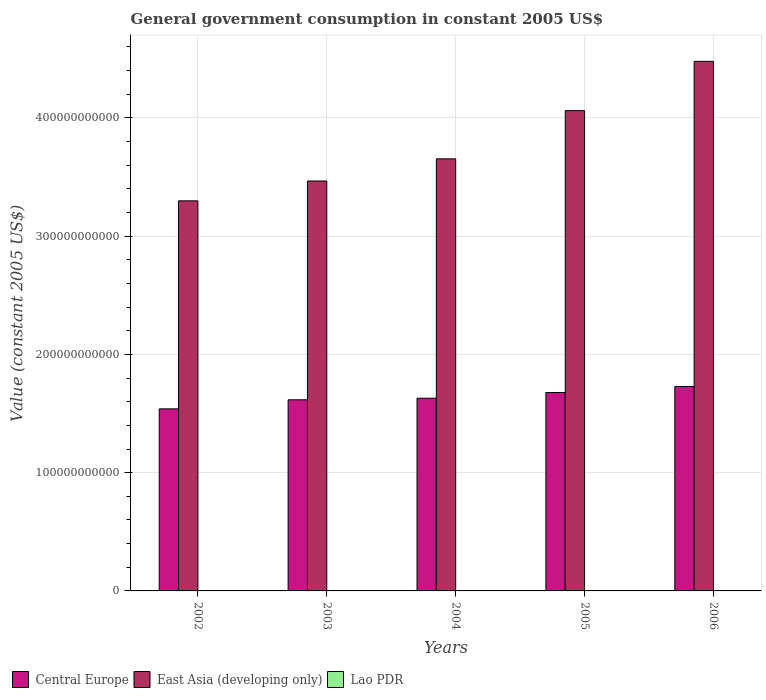How many different coloured bars are there?
Provide a short and direct response. 3. Are the number of bars on each tick of the X-axis equal?
Keep it short and to the point. Yes. How many bars are there on the 4th tick from the left?
Provide a succinct answer. 3. What is the label of the 2nd group of bars from the left?
Make the answer very short. 2003. In how many cases, is the number of bars for a given year not equal to the number of legend labels?
Offer a very short reply. 0. What is the government conusmption in Central Europe in 2003?
Your answer should be compact. 1.62e+11. Across all years, what is the maximum government conusmption in Lao PDR?
Your answer should be compact. 2.48e+08. Across all years, what is the minimum government conusmption in Central Europe?
Keep it short and to the point. 1.54e+11. In which year was the government conusmption in Central Europe maximum?
Make the answer very short. 2006. What is the total government conusmption in East Asia (developing only) in the graph?
Provide a short and direct response. 1.90e+12. What is the difference between the government conusmption in Central Europe in 2003 and that in 2005?
Keep it short and to the point. -6.17e+09. What is the difference between the government conusmption in East Asia (developing only) in 2005 and the government conusmption in Lao PDR in 2004?
Offer a very short reply. 4.06e+11. What is the average government conusmption in Lao PDR per year?
Your answer should be very brief. 1.93e+08. In the year 2002, what is the difference between the government conusmption in East Asia (developing only) and government conusmption in Central Europe?
Your answer should be compact. 1.76e+11. What is the ratio of the government conusmption in East Asia (developing only) in 2002 to that in 2004?
Your answer should be very brief. 0.9. Is the difference between the government conusmption in East Asia (developing only) in 2003 and 2004 greater than the difference between the government conusmption in Central Europe in 2003 and 2004?
Keep it short and to the point. No. What is the difference between the highest and the second highest government conusmption in East Asia (developing only)?
Offer a terse response. 4.17e+1. What is the difference between the highest and the lowest government conusmption in Lao PDR?
Your answer should be compact. 9.34e+07. In how many years, is the government conusmption in Lao PDR greater than the average government conusmption in Lao PDR taken over all years?
Provide a short and direct response. 2. What does the 3rd bar from the left in 2004 represents?
Offer a very short reply. Lao PDR. What does the 3rd bar from the right in 2003 represents?
Provide a succinct answer. Central Europe. Is it the case that in every year, the sum of the government conusmption in Lao PDR and government conusmption in East Asia (developing only) is greater than the government conusmption in Central Europe?
Provide a short and direct response. Yes. What is the difference between two consecutive major ticks on the Y-axis?
Your response must be concise. 1.00e+11. Are the values on the major ticks of Y-axis written in scientific E-notation?
Your response must be concise. No. Does the graph contain grids?
Provide a succinct answer. Yes. How many legend labels are there?
Give a very brief answer. 3. How are the legend labels stacked?
Offer a terse response. Horizontal. What is the title of the graph?
Your answer should be very brief. General government consumption in constant 2005 US$. Does "Kenya" appear as one of the legend labels in the graph?
Give a very brief answer. No. What is the label or title of the X-axis?
Your response must be concise. Years. What is the label or title of the Y-axis?
Provide a short and direct response. Value (constant 2005 US$). What is the Value (constant 2005 US$) of Central Europe in 2002?
Your answer should be very brief. 1.54e+11. What is the Value (constant 2005 US$) in East Asia (developing only) in 2002?
Make the answer very short. 3.30e+11. What is the Value (constant 2005 US$) in Lao PDR in 2002?
Your answer should be compact. 1.55e+08. What is the Value (constant 2005 US$) in Central Europe in 2003?
Give a very brief answer. 1.62e+11. What is the Value (constant 2005 US$) of East Asia (developing only) in 2003?
Give a very brief answer. 3.47e+11. What is the Value (constant 2005 US$) of Lao PDR in 2003?
Give a very brief answer. 1.64e+08. What is the Value (constant 2005 US$) of Central Europe in 2004?
Give a very brief answer. 1.63e+11. What is the Value (constant 2005 US$) of East Asia (developing only) in 2004?
Keep it short and to the point. 3.65e+11. What is the Value (constant 2005 US$) of Lao PDR in 2004?
Offer a terse response. 1.79e+08. What is the Value (constant 2005 US$) in Central Europe in 2005?
Your answer should be very brief. 1.68e+11. What is the Value (constant 2005 US$) in East Asia (developing only) in 2005?
Your answer should be compact. 4.06e+11. What is the Value (constant 2005 US$) in Lao PDR in 2005?
Keep it short and to the point. 2.22e+08. What is the Value (constant 2005 US$) of Central Europe in 2006?
Provide a short and direct response. 1.73e+11. What is the Value (constant 2005 US$) of East Asia (developing only) in 2006?
Provide a short and direct response. 4.48e+11. What is the Value (constant 2005 US$) in Lao PDR in 2006?
Provide a short and direct response. 2.48e+08. Across all years, what is the maximum Value (constant 2005 US$) of Central Europe?
Ensure brevity in your answer.  1.73e+11. Across all years, what is the maximum Value (constant 2005 US$) in East Asia (developing only)?
Provide a short and direct response. 4.48e+11. Across all years, what is the maximum Value (constant 2005 US$) of Lao PDR?
Your answer should be very brief. 2.48e+08. Across all years, what is the minimum Value (constant 2005 US$) of Central Europe?
Make the answer very short. 1.54e+11. Across all years, what is the minimum Value (constant 2005 US$) of East Asia (developing only)?
Your answer should be compact. 3.30e+11. Across all years, what is the minimum Value (constant 2005 US$) of Lao PDR?
Provide a succinct answer. 1.55e+08. What is the total Value (constant 2005 US$) of Central Europe in the graph?
Your response must be concise. 8.19e+11. What is the total Value (constant 2005 US$) in East Asia (developing only) in the graph?
Offer a terse response. 1.90e+12. What is the total Value (constant 2005 US$) of Lao PDR in the graph?
Your answer should be compact. 9.67e+08. What is the difference between the Value (constant 2005 US$) of Central Europe in 2002 and that in 2003?
Your answer should be compact. -7.67e+09. What is the difference between the Value (constant 2005 US$) in East Asia (developing only) in 2002 and that in 2003?
Your answer should be compact. -1.68e+1. What is the difference between the Value (constant 2005 US$) of Lao PDR in 2002 and that in 2003?
Your answer should be compact. -9.44e+06. What is the difference between the Value (constant 2005 US$) of Central Europe in 2002 and that in 2004?
Your answer should be compact. -9.01e+09. What is the difference between the Value (constant 2005 US$) of East Asia (developing only) in 2002 and that in 2004?
Offer a terse response. -3.55e+1. What is the difference between the Value (constant 2005 US$) in Lao PDR in 2002 and that in 2004?
Provide a short and direct response. -2.40e+07. What is the difference between the Value (constant 2005 US$) in Central Europe in 2002 and that in 2005?
Your answer should be very brief. -1.38e+1. What is the difference between the Value (constant 2005 US$) in East Asia (developing only) in 2002 and that in 2005?
Give a very brief answer. -7.63e+1. What is the difference between the Value (constant 2005 US$) of Lao PDR in 2002 and that in 2005?
Provide a succinct answer. -6.69e+07. What is the difference between the Value (constant 2005 US$) of Central Europe in 2002 and that in 2006?
Ensure brevity in your answer.  -1.89e+1. What is the difference between the Value (constant 2005 US$) of East Asia (developing only) in 2002 and that in 2006?
Provide a short and direct response. -1.18e+11. What is the difference between the Value (constant 2005 US$) of Lao PDR in 2002 and that in 2006?
Your answer should be compact. -9.34e+07. What is the difference between the Value (constant 2005 US$) in Central Europe in 2003 and that in 2004?
Keep it short and to the point. -1.34e+09. What is the difference between the Value (constant 2005 US$) of East Asia (developing only) in 2003 and that in 2004?
Make the answer very short. -1.87e+1. What is the difference between the Value (constant 2005 US$) of Lao PDR in 2003 and that in 2004?
Give a very brief answer. -1.46e+07. What is the difference between the Value (constant 2005 US$) in Central Europe in 2003 and that in 2005?
Ensure brevity in your answer.  -6.17e+09. What is the difference between the Value (constant 2005 US$) in East Asia (developing only) in 2003 and that in 2005?
Your response must be concise. -5.95e+1. What is the difference between the Value (constant 2005 US$) in Lao PDR in 2003 and that in 2005?
Make the answer very short. -5.75e+07. What is the difference between the Value (constant 2005 US$) in Central Europe in 2003 and that in 2006?
Give a very brief answer. -1.12e+1. What is the difference between the Value (constant 2005 US$) of East Asia (developing only) in 2003 and that in 2006?
Offer a very short reply. -1.01e+11. What is the difference between the Value (constant 2005 US$) of Lao PDR in 2003 and that in 2006?
Provide a succinct answer. -8.39e+07. What is the difference between the Value (constant 2005 US$) of Central Europe in 2004 and that in 2005?
Provide a succinct answer. -4.83e+09. What is the difference between the Value (constant 2005 US$) in East Asia (developing only) in 2004 and that in 2005?
Provide a short and direct response. -4.07e+1. What is the difference between the Value (constant 2005 US$) of Lao PDR in 2004 and that in 2005?
Offer a terse response. -4.29e+07. What is the difference between the Value (constant 2005 US$) in Central Europe in 2004 and that in 2006?
Your answer should be compact. -9.87e+09. What is the difference between the Value (constant 2005 US$) of East Asia (developing only) in 2004 and that in 2006?
Provide a short and direct response. -8.24e+1. What is the difference between the Value (constant 2005 US$) of Lao PDR in 2004 and that in 2006?
Your answer should be compact. -6.93e+07. What is the difference between the Value (constant 2005 US$) of Central Europe in 2005 and that in 2006?
Keep it short and to the point. -5.04e+09. What is the difference between the Value (constant 2005 US$) in East Asia (developing only) in 2005 and that in 2006?
Make the answer very short. -4.17e+1. What is the difference between the Value (constant 2005 US$) of Lao PDR in 2005 and that in 2006?
Offer a terse response. -2.64e+07. What is the difference between the Value (constant 2005 US$) in Central Europe in 2002 and the Value (constant 2005 US$) in East Asia (developing only) in 2003?
Make the answer very short. -1.93e+11. What is the difference between the Value (constant 2005 US$) in Central Europe in 2002 and the Value (constant 2005 US$) in Lao PDR in 2003?
Your response must be concise. 1.54e+11. What is the difference between the Value (constant 2005 US$) of East Asia (developing only) in 2002 and the Value (constant 2005 US$) of Lao PDR in 2003?
Provide a succinct answer. 3.30e+11. What is the difference between the Value (constant 2005 US$) of Central Europe in 2002 and the Value (constant 2005 US$) of East Asia (developing only) in 2004?
Your response must be concise. -2.11e+11. What is the difference between the Value (constant 2005 US$) of Central Europe in 2002 and the Value (constant 2005 US$) of Lao PDR in 2004?
Your answer should be compact. 1.54e+11. What is the difference between the Value (constant 2005 US$) of East Asia (developing only) in 2002 and the Value (constant 2005 US$) of Lao PDR in 2004?
Provide a succinct answer. 3.30e+11. What is the difference between the Value (constant 2005 US$) in Central Europe in 2002 and the Value (constant 2005 US$) in East Asia (developing only) in 2005?
Ensure brevity in your answer.  -2.52e+11. What is the difference between the Value (constant 2005 US$) of Central Europe in 2002 and the Value (constant 2005 US$) of Lao PDR in 2005?
Give a very brief answer. 1.54e+11. What is the difference between the Value (constant 2005 US$) of East Asia (developing only) in 2002 and the Value (constant 2005 US$) of Lao PDR in 2005?
Your response must be concise. 3.30e+11. What is the difference between the Value (constant 2005 US$) of Central Europe in 2002 and the Value (constant 2005 US$) of East Asia (developing only) in 2006?
Keep it short and to the point. -2.94e+11. What is the difference between the Value (constant 2005 US$) of Central Europe in 2002 and the Value (constant 2005 US$) of Lao PDR in 2006?
Your response must be concise. 1.54e+11. What is the difference between the Value (constant 2005 US$) in East Asia (developing only) in 2002 and the Value (constant 2005 US$) in Lao PDR in 2006?
Offer a terse response. 3.30e+11. What is the difference between the Value (constant 2005 US$) of Central Europe in 2003 and the Value (constant 2005 US$) of East Asia (developing only) in 2004?
Give a very brief answer. -2.04e+11. What is the difference between the Value (constant 2005 US$) in Central Europe in 2003 and the Value (constant 2005 US$) in Lao PDR in 2004?
Offer a very short reply. 1.61e+11. What is the difference between the Value (constant 2005 US$) of East Asia (developing only) in 2003 and the Value (constant 2005 US$) of Lao PDR in 2004?
Make the answer very short. 3.46e+11. What is the difference between the Value (constant 2005 US$) in Central Europe in 2003 and the Value (constant 2005 US$) in East Asia (developing only) in 2005?
Ensure brevity in your answer.  -2.44e+11. What is the difference between the Value (constant 2005 US$) of Central Europe in 2003 and the Value (constant 2005 US$) of Lao PDR in 2005?
Your answer should be compact. 1.61e+11. What is the difference between the Value (constant 2005 US$) of East Asia (developing only) in 2003 and the Value (constant 2005 US$) of Lao PDR in 2005?
Provide a succinct answer. 3.46e+11. What is the difference between the Value (constant 2005 US$) of Central Europe in 2003 and the Value (constant 2005 US$) of East Asia (developing only) in 2006?
Your response must be concise. -2.86e+11. What is the difference between the Value (constant 2005 US$) in Central Europe in 2003 and the Value (constant 2005 US$) in Lao PDR in 2006?
Provide a short and direct response. 1.61e+11. What is the difference between the Value (constant 2005 US$) in East Asia (developing only) in 2003 and the Value (constant 2005 US$) in Lao PDR in 2006?
Give a very brief answer. 3.46e+11. What is the difference between the Value (constant 2005 US$) of Central Europe in 2004 and the Value (constant 2005 US$) of East Asia (developing only) in 2005?
Give a very brief answer. -2.43e+11. What is the difference between the Value (constant 2005 US$) in Central Europe in 2004 and the Value (constant 2005 US$) in Lao PDR in 2005?
Offer a terse response. 1.63e+11. What is the difference between the Value (constant 2005 US$) in East Asia (developing only) in 2004 and the Value (constant 2005 US$) in Lao PDR in 2005?
Offer a terse response. 3.65e+11. What is the difference between the Value (constant 2005 US$) of Central Europe in 2004 and the Value (constant 2005 US$) of East Asia (developing only) in 2006?
Provide a succinct answer. -2.85e+11. What is the difference between the Value (constant 2005 US$) in Central Europe in 2004 and the Value (constant 2005 US$) in Lao PDR in 2006?
Give a very brief answer. 1.63e+11. What is the difference between the Value (constant 2005 US$) in East Asia (developing only) in 2004 and the Value (constant 2005 US$) in Lao PDR in 2006?
Ensure brevity in your answer.  3.65e+11. What is the difference between the Value (constant 2005 US$) of Central Europe in 2005 and the Value (constant 2005 US$) of East Asia (developing only) in 2006?
Keep it short and to the point. -2.80e+11. What is the difference between the Value (constant 2005 US$) in Central Europe in 2005 and the Value (constant 2005 US$) in Lao PDR in 2006?
Keep it short and to the point. 1.68e+11. What is the difference between the Value (constant 2005 US$) in East Asia (developing only) in 2005 and the Value (constant 2005 US$) in Lao PDR in 2006?
Your answer should be very brief. 4.06e+11. What is the average Value (constant 2005 US$) of Central Europe per year?
Ensure brevity in your answer.  1.64e+11. What is the average Value (constant 2005 US$) in East Asia (developing only) per year?
Offer a very short reply. 3.79e+11. What is the average Value (constant 2005 US$) in Lao PDR per year?
Your answer should be very brief. 1.93e+08. In the year 2002, what is the difference between the Value (constant 2005 US$) in Central Europe and Value (constant 2005 US$) in East Asia (developing only)?
Provide a succinct answer. -1.76e+11. In the year 2002, what is the difference between the Value (constant 2005 US$) of Central Europe and Value (constant 2005 US$) of Lao PDR?
Offer a very short reply. 1.54e+11. In the year 2002, what is the difference between the Value (constant 2005 US$) in East Asia (developing only) and Value (constant 2005 US$) in Lao PDR?
Offer a very short reply. 3.30e+11. In the year 2003, what is the difference between the Value (constant 2005 US$) in Central Europe and Value (constant 2005 US$) in East Asia (developing only)?
Your response must be concise. -1.85e+11. In the year 2003, what is the difference between the Value (constant 2005 US$) of Central Europe and Value (constant 2005 US$) of Lao PDR?
Provide a succinct answer. 1.61e+11. In the year 2003, what is the difference between the Value (constant 2005 US$) of East Asia (developing only) and Value (constant 2005 US$) of Lao PDR?
Your answer should be compact. 3.46e+11. In the year 2004, what is the difference between the Value (constant 2005 US$) in Central Europe and Value (constant 2005 US$) in East Asia (developing only)?
Your response must be concise. -2.02e+11. In the year 2004, what is the difference between the Value (constant 2005 US$) of Central Europe and Value (constant 2005 US$) of Lao PDR?
Your answer should be very brief. 1.63e+11. In the year 2004, what is the difference between the Value (constant 2005 US$) in East Asia (developing only) and Value (constant 2005 US$) in Lao PDR?
Keep it short and to the point. 3.65e+11. In the year 2005, what is the difference between the Value (constant 2005 US$) in Central Europe and Value (constant 2005 US$) in East Asia (developing only)?
Offer a terse response. -2.38e+11. In the year 2005, what is the difference between the Value (constant 2005 US$) in Central Europe and Value (constant 2005 US$) in Lao PDR?
Offer a very short reply. 1.68e+11. In the year 2005, what is the difference between the Value (constant 2005 US$) of East Asia (developing only) and Value (constant 2005 US$) of Lao PDR?
Make the answer very short. 4.06e+11. In the year 2006, what is the difference between the Value (constant 2005 US$) in Central Europe and Value (constant 2005 US$) in East Asia (developing only)?
Ensure brevity in your answer.  -2.75e+11. In the year 2006, what is the difference between the Value (constant 2005 US$) of Central Europe and Value (constant 2005 US$) of Lao PDR?
Offer a very short reply. 1.73e+11. In the year 2006, what is the difference between the Value (constant 2005 US$) in East Asia (developing only) and Value (constant 2005 US$) in Lao PDR?
Offer a terse response. 4.48e+11. What is the ratio of the Value (constant 2005 US$) in Central Europe in 2002 to that in 2003?
Give a very brief answer. 0.95. What is the ratio of the Value (constant 2005 US$) in East Asia (developing only) in 2002 to that in 2003?
Provide a short and direct response. 0.95. What is the ratio of the Value (constant 2005 US$) in Lao PDR in 2002 to that in 2003?
Keep it short and to the point. 0.94. What is the ratio of the Value (constant 2005 US$) of Central Europe in 2002 to that in 2004?
Your response must be concise. 0.94. What is the ratio of the Value (constant 2005 US$) of East Asia (developing only) in 2002 to that in 2004?
Make the answer very short. 0.9. What is the ratio of the Value (constant 2005 US$) of Lao PDR in 2002 to that in 2004?
Ensure brevity in your answer.  0.87. What is the ratio of the Value (constant 2005 US$) in Central Europe in 2002 to that in 2005?
Provide a short and direct response. 0.92. What is the ratio of the Value (constant 2005 US$) of East Asia (developing only) in 2002 to that in 2005?
Your answer should be compact. 0.81. What is the ratio of the Value (constant 2005 US$) in Lao PDR in 2002 to that in 2005?
Make the answer very short. 0.7. What is the ratio of the Value (constant 2005 US$) of Central Europe in 2002 to that in 2006?
Offer a terse response. 0.89. What is the ratio of the Value (constant 2005 US$) in East Asia (developing only) in 2002 to that in 2006?
Offer a very short reply. 0.74. What is the ratio of the Value (constant 2005 US$) of Lao PDR in 2002 to that in 2006?
Make the answer very short. 0.62. What is the ratio of the Value (constant 2005 US$) of East Asia (developing only) in 2003 to that in 2004?
Your answer should be very brief. 0.95. What is the ratio of the Value (constant 2005 US$) of Lao PDR in 2003 to that in 2004?
Keep it short and to the point. 0.92. What is the ratio of the Value (constant 2005 US$) of Central Europe in 2003 to that in 2005?
Provide a succinct answer. 0.96. What is the ratio of the Value (constant 2005 US$) in East Asia (developing only) in 2003 to that in 2005?
Give a very brief answer. 0.85. What is the ratio of the Value (constant 2005 US$) of Lao PDR in 2003 to that in 2005?
Provide a succinct answer. 0.74. What is the ratio of the Value (constant 2005 US$) in Central Europe in 2003 to that in 2006?
Provide a short and direct response. 0.94. What is the ratio of the Value (constant 2005 US$) in East Asia (developing only) in 2003 to that in 2006?
Give a very brief answer. 0.77. What is the ratio of the Value (constant 2005 US$) in Lao PDR in 2003 to that in 2006?
Your answer should be compact. 0.66. What is the ratio of the Value (constant 2005 US$) of Central Europe in 2004 to that in 2005?
Offer a terse response. 0.97. What is the ratio of the Value (constant 2005 US$) in East Asia (developing only) in 2004 to that in 2005?
Offer a terse response. 0.9. What is the ratio of the Value (constant 2005 US$) of Lao PDR in 2004 to that in 2005?
Provide a short and direct response. 0.81. What is the ratio of the Value (constant 2005 US$) of Central Europe in 2004 to that in 2006?
Give a very brief answer. 0.94. What is the ratio of the Value (constant 2005 US$) of East Asia (developing only) in 2004 to that in 2006?
Make the answer very short. 0.82. What is the ratio of the Value (constant 2005 US$) in Lao PDR in 2004 to that in 2006?
Offer a very short reply. 0.72. What is the ratio of the Value (constant 2005 US$) in Central Europe in 2005 to that in 2006?
Keep it short and to the point. 0.97. What is the ratio of the Value (constant 2005 US$) in East Asia (developing only) in 2005 to that in 2006?
Your response must be concise. 0.91. What is the ratio of the Value (constant 2005 US$) of Lao PDR in 2005 to that in 2006?
Your answer should be very brief. 0.89. What is the difference between the highest and the second highest Value (constant 2005 US$) in Central Europe?
Your response must be concise. 5.04e+09. What is the difference between the highest and the second highest Value (constant 2005 US$) in East Asia (developing only)?
Your answer should be compact. 4.17e+1. What is the difference between the highest and the second highest Value (constant 2005 US$) of Lao PDR?
Provide a succinct answer. 2.64e+07. What is the difference between the highest and the lowest Value (constant 2005 US$) of Central Europe?
Your answer should be very brief. 1.89e+1. What is the difference between the highest and the lowest Value (constant 2005 US$) in East Asia (developing only)?
Offer a very short reply. 1.18e+11. What is the difference between the highest and the lowest Value (constant 2005 US$) in Lao PDR?
Ensure brevity in your answer.  9.34e+07. 